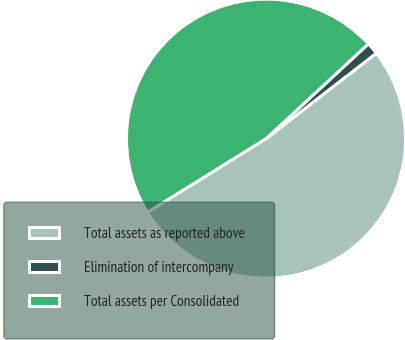Convert chart. <chart><loc_0><loc_0><loc_500><loc_500><pie_chart><fcel>Total assets as reported above<fcel>Elimination of intercompany<fcel>Total assets per Consolidated<nl><fcel>51.65%<fcel>1.4%<fcel>46.95%<nl></chart> 